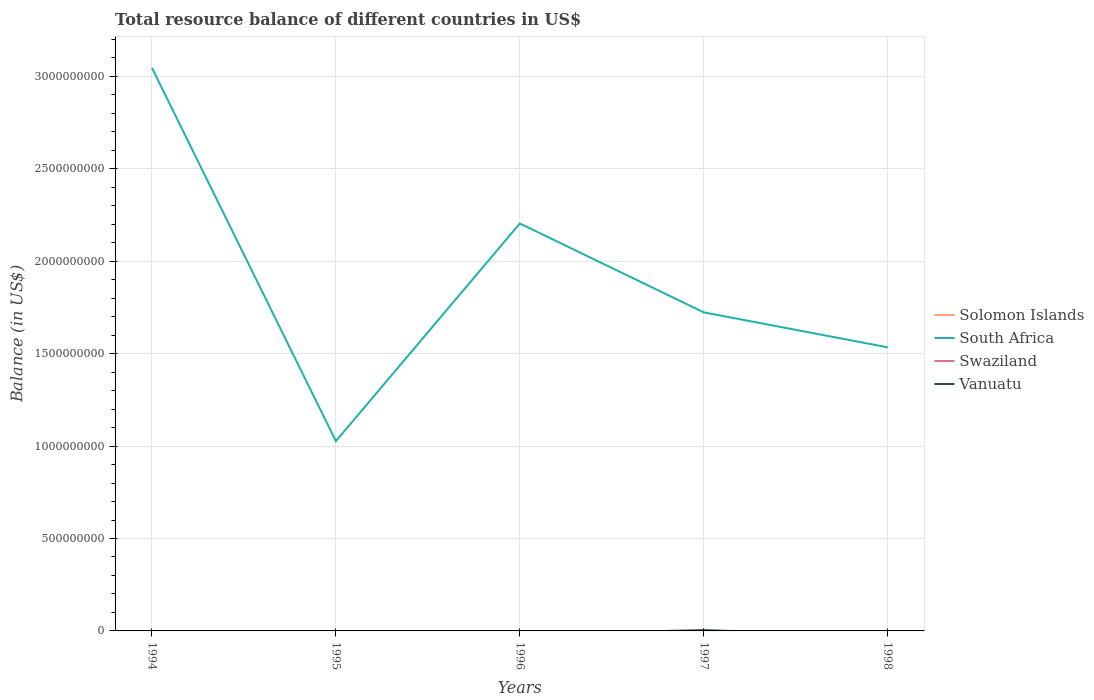Is the number of lines equal to the number of legend labels?
Keep it short and to the point. No. What is the total total resource balance in South Africa in the graph?
Offer a very short reply. -5.08e+08. What is the difference between the highest and the second highest total resource balance in South Africa?
Your response must be concise. 2.02e+09. Is the total resource balance in Vanuatu strictly greater than the total resource balance in Solomon Islands over the years?
Your answer should be very brief. No. Does the graph contain any zero values?
Provide a succinct answer. Yes. Does the graph contain grids?
Keep it short and to the point. Yes. How many legend labels are there?
Offer a very short reply. 4. How are the legend labels stacked?
Offer a terse response. Vertical. What is the title of the graph?
Make the answer very short. Total resource balance of different countries in US$. Does "El Salvador" appear as one of the legend labels in the graph?
Your answer should be very brief. No. What is the label or title of the X-axis?
Provide a succinct answer. Years. What is the label or title of the Y-axis?
Give a very brief answer. Balance (in US$). What is the Balance (in US$) in Solomon Islands in 1994?
Your response must be concise. 0. What is the Balance (in US$) in South Africa in 1994?
Your response must be concise. 3.05e+09. What is the Balance (in US$) in Vanuatu in 1994?
Your answer should be compact. 0. What is the Balance (in US$) in South Africa in 1995?
Make the answer very short. 1.03e+09. What is the Balance (in US$) of Swaziland in 1995?
Ensure brevity in your answer.  0. What is the Balance (in US$) of Vanuatu in 1995?
Keep it short and to the point. 0. What is the Balance (in US$) in South Africa in 1996?
Ensure brevity in your answer.  2.20e+09. What is the Balance (in US$) in Vanuatu in 1996?
Your answer should be very brief. 0. What is the Balance (in US$) of South Africa in 1997?
Your response must be concise. 1.72e+09. What is the Balance (in US$) of Swaziland in 1997?
Offer a terse response. 0. What is the Balance (in US$) of Vanuatu in 1997?
Provide a succinct answer. 4.44e+06. What is the Balance (in US$) of South Africa in 1998?
Keep it short and to the point. 1.53e+09. What is the Balance (in US$) of Swaziland in 1998?
Offer a very short reply. 0. What is the Balance (in US$) of Vanuatu in 1998?
Keep it short and to the point. 0. Across all years, what is the maximum Balance (in US$) in South Africa?
Provide a succinct answer. 3.05e+09. Across all years, what is the maximum Balance (in US$) in Vanuatu?
Ensure brevity in your answer.  4.44e+06. Across all years, what is the minimum Balance (in US$) in South Africa?
Provide a short and direct response. 1.03e+09. What is the total Balance (in US$) of South Africa in the graph?
Offer a terse response. 9.53e+09. What is the total Balance (in US$) in Swaziland in the graph?
Keep it short and to the point. 0. What is the total Balance (in US$) of Vanuatu in the graph?
Your answer should be compact. 4.44e+06. What is the difference between the Balance (in US$) in South Africa in 1994 and that in 1995?
Make the answer very short. 2.02e+09. What is the difference between the Balance (in US$) in South Africa in 1994 and that in 1996?
Keep it short and to the point. 8.42e+08. What is the difference between the Balance (in US$) of South Africa in 1994 and that in 1997?
Provide a succinct answer. 1.32e+09. What is the difference between the Balance (in US$) in South Africa in 1994 and that in 1998?
Make the answer very short. 1.51e+09. What is the difference between the Balance (in US$) in South Africa in 1995 and that in 1996?
Provide a succinct answer. -1.18e+09. What is the difference between the Balance (in US$) of South Africa in 1995 and that in 1997?
Ensure brevity in your answer.  -6.97e+08. What is the difference between the Balance (in US$) in South Africa in 1995 and that in 1998?
Your response must be concise. -5.08e+08. What is the difference between the Balance (in US$) of South Africa in 1996 and that in 1997?
Offer a terse response. 4.81e+08. What is the difference between the Balance (in US$) in South Africa in 1996 and that in 1998?
Your answer should be compact. 6.70e+08. What is the difference between the Balance (in US$) in South Africa in 1997 and that in 1998?
Provide a short and direct response. 1.89e+08. What is the difference between the Balance (in US$) in South Africa in 1994 and the Balance (in US$) in Vanuatu in 1997?
Your answer should be very brief. 3.04e+09. What is the difference between the Balance (in US$) of South Africa in 1995 and the Balance (in US$) of Vanuatu in 1997?
Offer a very short reply. 1.02e+09. What is the difference between the Balance (in US$) in South Africa in 1996 and the Balance (in US$) in Vanuatu in 1997?
Offer a very short reply. 2.20e+09. What is the average Balance (in US$) of Solomon Islands per year?
Offer a terse response. 0. What is the average Balance (in US$) in South Africa per year?
Make the answer very short. 1.91e+09. What is the average Balance (in US$) of Swaziland per year?
Offer a terse response. 0. What is the average Balance (in US$) of Vanuatu per year?
Your answer should be compact. 8.87e+05. In the year 1997, what is the difference between the Balance (in US$) of South Africa and Balance (in US$) of Vanuatu?
Offer a terse response. 1.72e+09. What is the ratio of the Balance (in US$) of South Africa in 1994 to that in 1995?
Ensure brevity in your answer.  2.97. What is the ratio of the Balance (in US$) of South Africa in 1994 to that in 1996?
Your response must be concise. 1.38. What is the ratio of the Balance (in US$) in South Africa in 1994 to that in 1997?
Provide a succinct answer. 1.77. What is the ratio of the Balance (in US$) in South Africa in 1994 to that in 1998?
Your answer should be very brief. 1.99. What is the ratio of the Balance (in US$) in South Africa in 1995 to that in 1996?
Your response must be concise. 0.47. What is the ratio of the Balance (in US$) in South Africa in 1995 to that in 1997?
Provide a short and direct response. 0.6. What is the ratio of the Balance (in US$) of South Africa in 1995 to that in 1998?
Your response must be concise. 0.67. What is the ratio of the Balance (in US$) in South Africa in 1996 to that in 1997?
Give a very brief answer. 1.28. What is the ratio of the Balance (in US$) of South Africa in 1996 to that in 1998?
Provide a succinct answer. 1.44. What is the ratio of the Balance (in US$) of South Africa in 1997 to that in 1998?
Provide a succinct answer. 1.12. What is the difference between the highest and the second highest Balance (in US$) in South Africa?
Your answer should be compact. 8.42e+08. What is the difference between the highest and the lowest Balance (in US$) of South Africa?
Give a very brief answer. 2.02e+09. What is the difference between the highest and the lowest Balance (in US$) of Vanuatu?
Offer a terse response. 4.44e+06. 